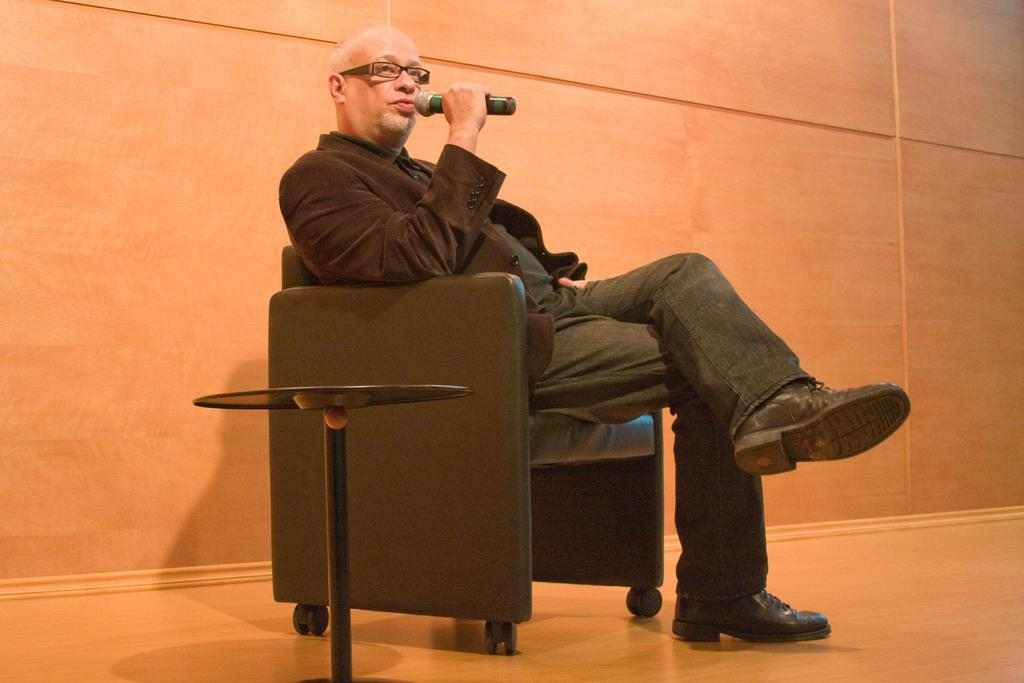What is the person in the image doing? The person is sitting on a chair and holding a microphone. What can be seen on the person's face? The person is wearing glasses. What is the person wearing? The person is wearing a black suit. What color is the wall in the background? There is a red-colored wall in the background. What type of quartz can be seen on the person's wrist in the image? There is no quartz visible on the person's wrist in the image. What month is it in the image? The image does not provide any information about the month or time of year. 